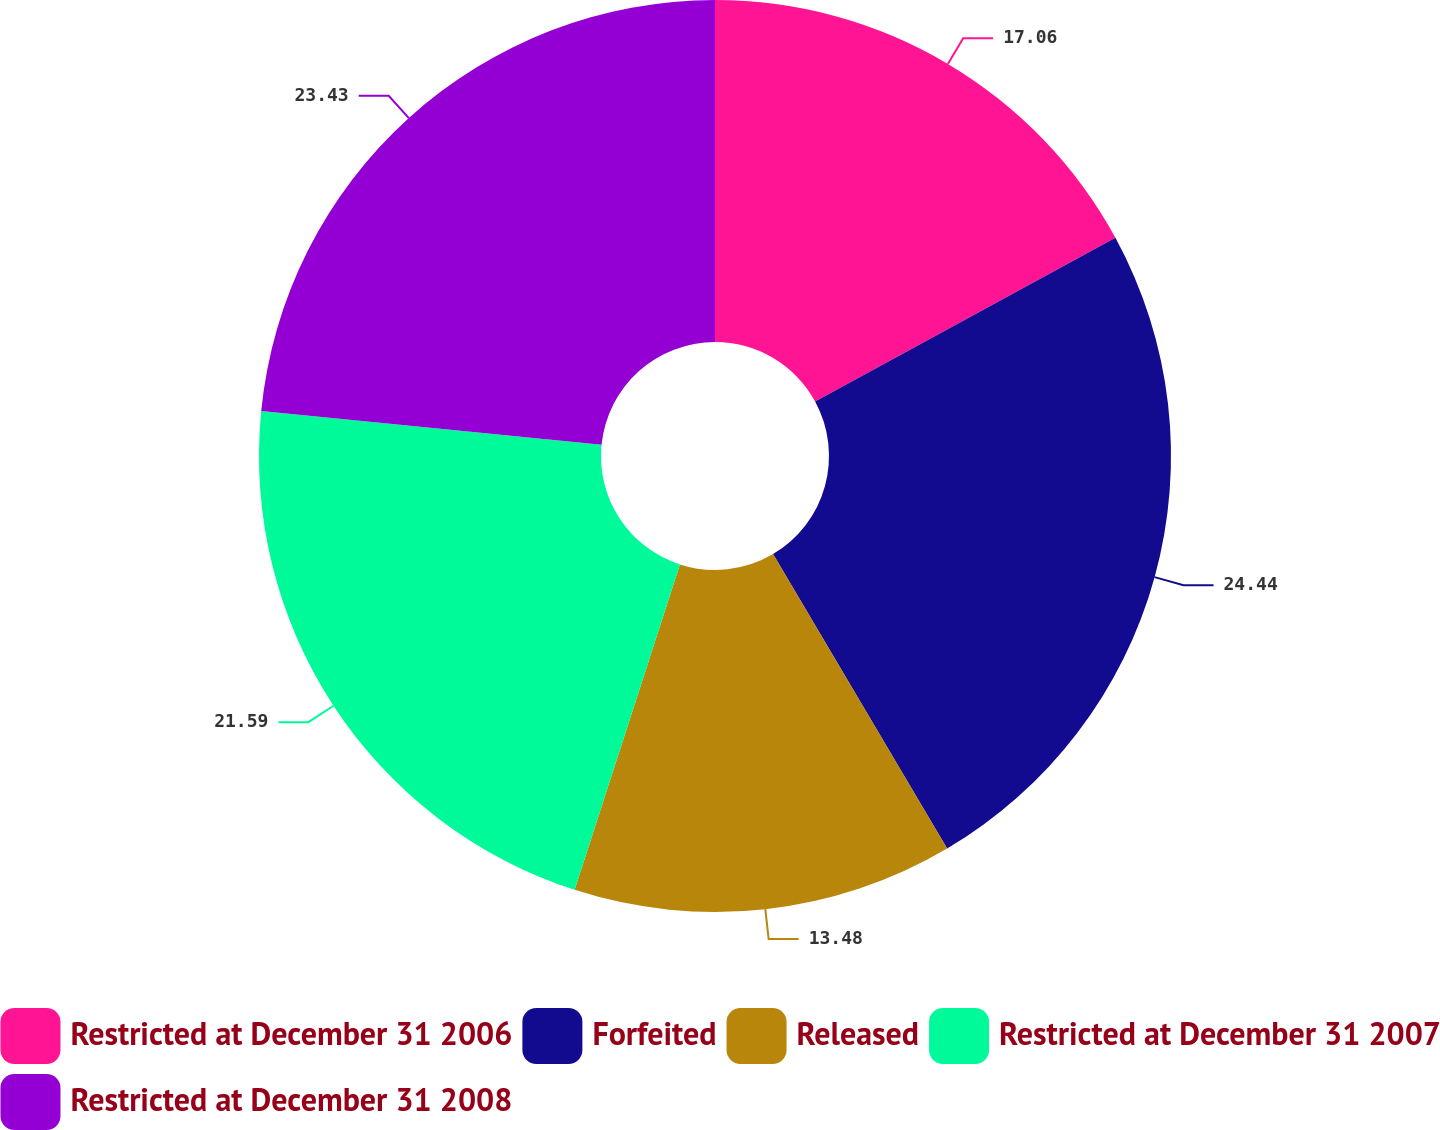Convert chart. <chart><loc_0><loc_0><loc_500><loc_500><pie_chart><fcel>Restricted at December 31 2006<fcel>Forfeited<fcel>Released<fcel>Restricted at December 31 2007<fcel>Restricted at December 31 2008<nl><fcel>17.06%<fcel>24.44%<fcel>13.48%<fcel>21.59%<fcel>23.43%<nl></chart> 